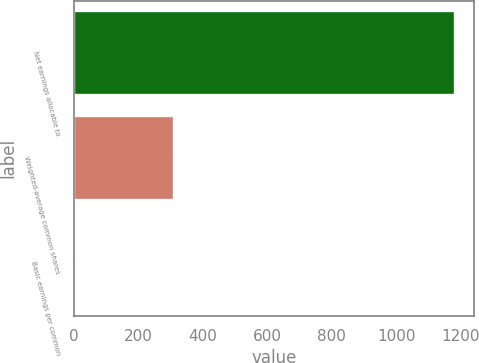<chart> <loc_0><loc_0><loc_500><loc_500><bar_chart><fcel>Net earnings allocable to<fcel>Weighted-average common shares<fcel>Basic earnings per common<nl><fcel>1182<fcel>312<fcel>3.78<nl></chart> 